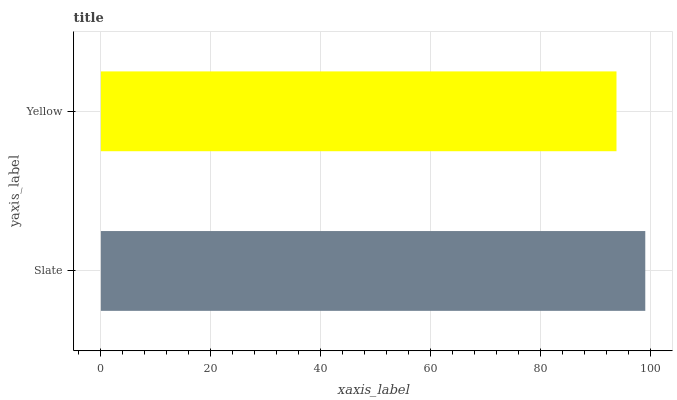Is Yellow the minimum?
Answer yes or no. Yes. Is Slate the maximum?
Answer yes or no. Yes. Is Yellow the maximum?
Answer yes or no. No. Is Slate greater than Yellow?
Answer yes or no. Yes. Is Yellow less than Slate?
Answer yes or no. Yes. Is Yellow greater than Slate?
Answer yes or no. No. Is Slate less than Yellow?
Answer yes or no. No. Is Slate the high median?
Answer yes or no. Yes. Is Yellow the low median?
Answer yes or no. Yes. Is Yellow the high median?
Answer yes or no. No. Is Slate the low median?
Answer yes or no. No. 